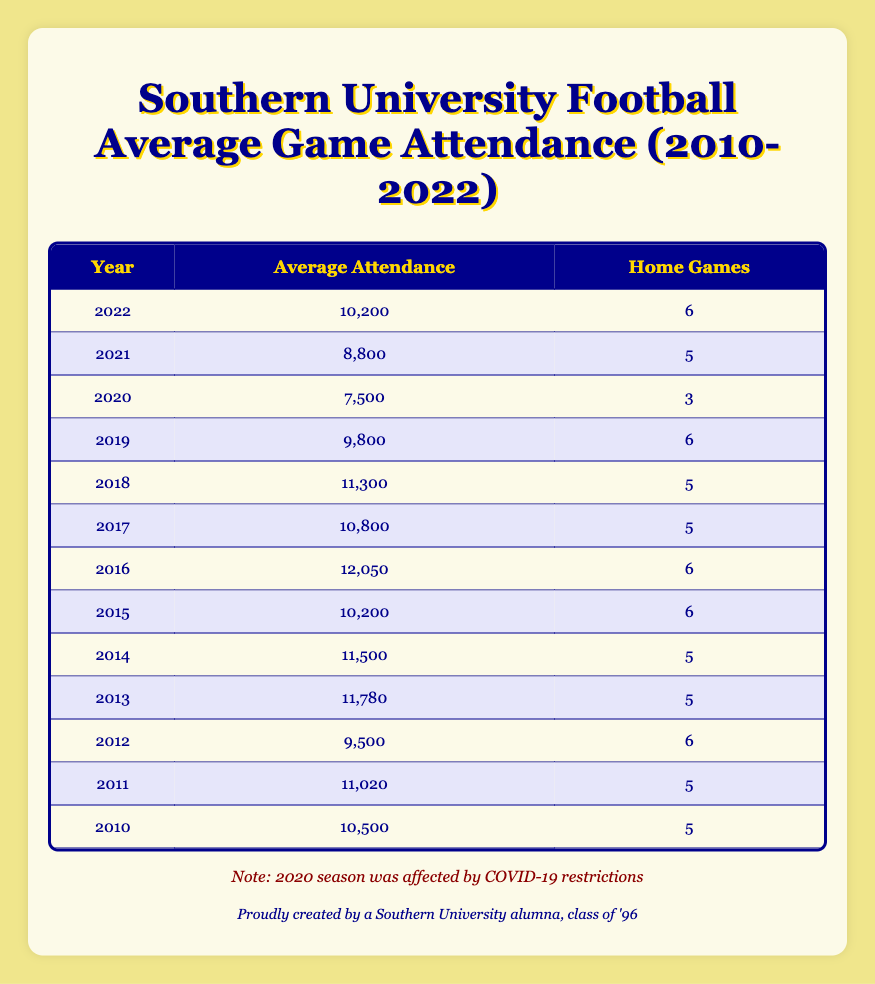What was the average attendance in 2015? Referring to the table under the year 2015, the average attendance listed is 10,200.
Answer: 10,200 Which year had the highest average attendance? Looking at the "Average Attendance" column, the highest value is 12,050, which corresponds to the year 2016.
Answer: 2016 What is the total number of home games played from 2010 to 2022? Adding the "Home Game Count" for each year: 5 + 5 + 6 + 5 + 5 + 6 + 6 + 5 + 5 + 6 + 3 + 5 + 6 = 64.
Answer: 64 Was the average attendance in 2021 higher than in 2019? The average attendance in 2021 is 8,800, and in 2019 it is 9,800. Since 8,800 is less than 9,800, the answer is no.
Answer: No What is the average attendance across all years? To find this, sum up all average attendance values (10,500 + 11,020 + 9,500 + 11,780 + 11,500 + 10,200 + 12,050 + 10,800 + 11,300 + 9,800 + 7,500 + 8,800 + 10,200) = 136,750 and divide by the number of years (13). So, the average is 136,750 / 13 = 10,530.76, which rounds to 10,531.
Answer: 10,531 In which years did the average attendance fall below 10,000? Checking the average attendance values, the years with an average attendance below 10,000 are: 2012 (9,500), 2019 (9,800), and 2020 (7,500).
Answer: 2012, 2019, 2020 What percentage of the total home games in the data set were played in years having average attendance above 10,000? The qualifying years are: 2010, 2011, 2013, 2014, 2016, 2017, 2018, 2022 which sum to 43 home games (5 + 5 + 5 + 5 + 6 + 5 + 5 + 6 = 43). The total number of home games is 64, so the percentage is (43/64) * 100 = 67.19%.
Answer: 67.19% Did any year have an average attendance of exactly 9,800? Looking through the table, the year 2019 has an average attendance of 9,800, confirming that there is indeed a year with that specific attendance.
Answer: Yes What was the year-to-year change in average attendance from 2020 to 2021? To find the change, subtract the average attendance in 2020 (7,500) from 2021 (8,800): 8,800 - 7,500 = 1,300. Thus, the change is an increase of 1,300.
Answer: 1,300 